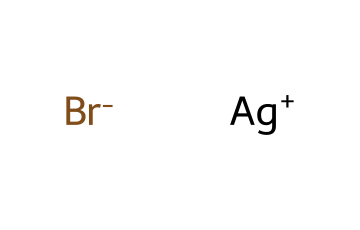What is the cation in this chemical structure? The cation is the positively charged ion in the structure. In the provided SMILES, [Ag+] indicates that silver (Ag) carries a positive charge, making it the cation.
Answer: silver What is the anion in this chemical structure? The anion is the negatively charged ion in the structure. The SMILES representation shows [Br-], which indicates that bromine (Br) carries a negative charge, identifying it as the anion.
Answer: bromine How many atoms are present in this molecule? To find the total number of atoms, we count the silver (Ag) atom and the bromine (Br) atom from the SMILES. There are two distinct atoms: Ag and Br.
Answer: two What type of bond is present between Ag and Br? The bond between Ag and Br is ionic, as Ag is a metal that donates an electron to Br, a non-metal, creating an electrostatic attraction. This is indicative of ionic bonding.
Answer: ionic What is the primary function of silver halide in photography? Silver halide is used in photography to capture images through light exposure, where it undergoes a photochemical reaction that leads to image formation.
Answer: light exposure Why is silver halide considered photoreactive? Silver halide is photoreactive because it undergoes chemical changes when exposed to light; specifically, the silver ions can reduce to metallic silver, which is crucial in image development.
Answer: undergoes changes 